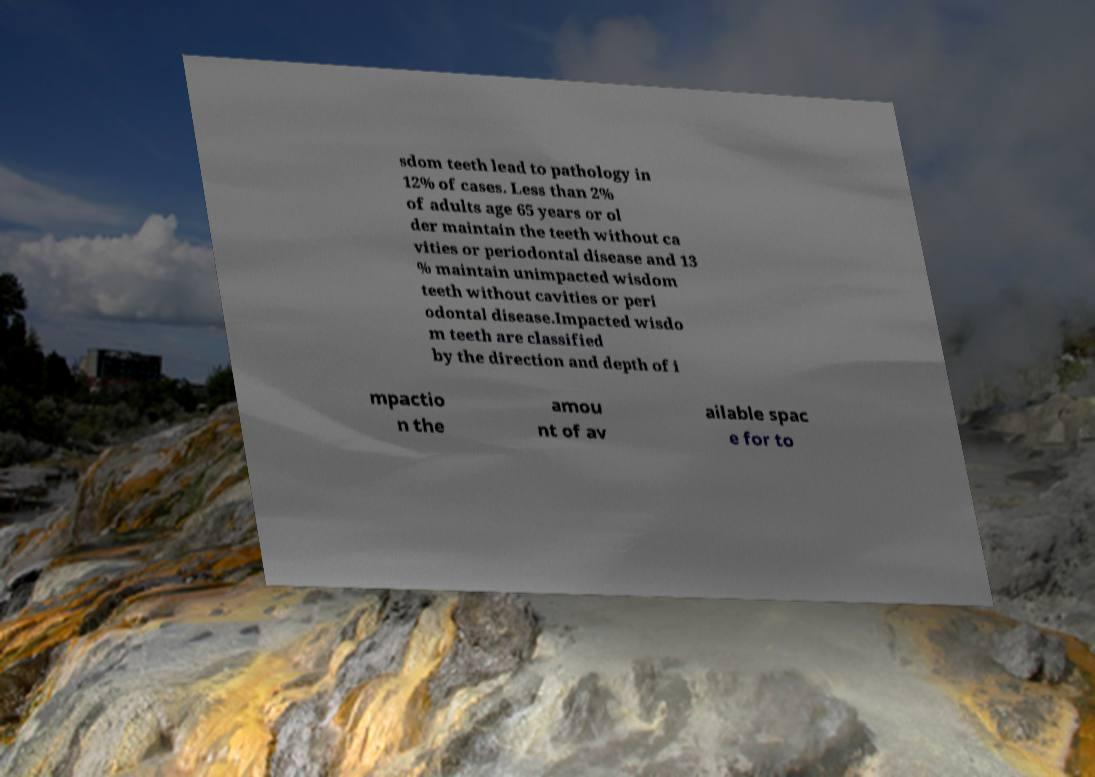Could you assist in decoding the text presented in this image and type it out clearly? sdom teeth lead to pathology in 12% of cases. Less than 2% of adults age 65 years or ol der maintain the teeth without ca vities or periodontal disease and 13 % maintain unimpacted wisdom teeth without cavities or peri odontal disease.Impacted wisdo m teeth are classified by the direction and depth of i mpactio n the amou nt of av ailable spac e for to 